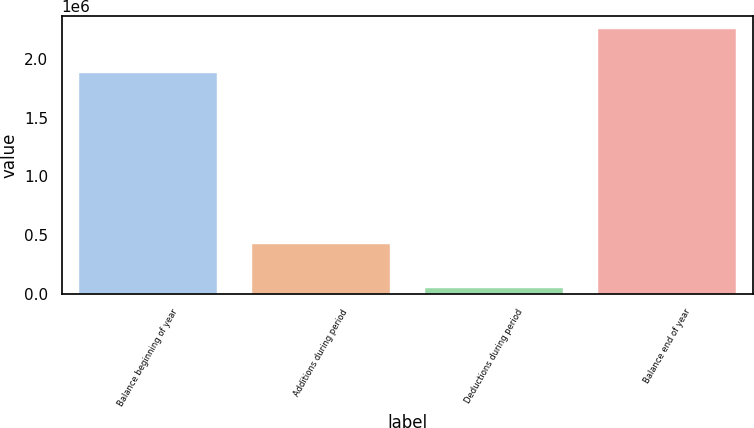Convert chart. <chart><loc_0><loc_0><loc_500><loc_500><bar_chart><fcel>Balance beginning of year<fcel>Additions during period<fcel>Deductions during period<fcel>Balance end of year<nl><fcel>1.87405e+06<fcel>429057<fcel>51843<fcel>2.25127e+06<nl></chart> 